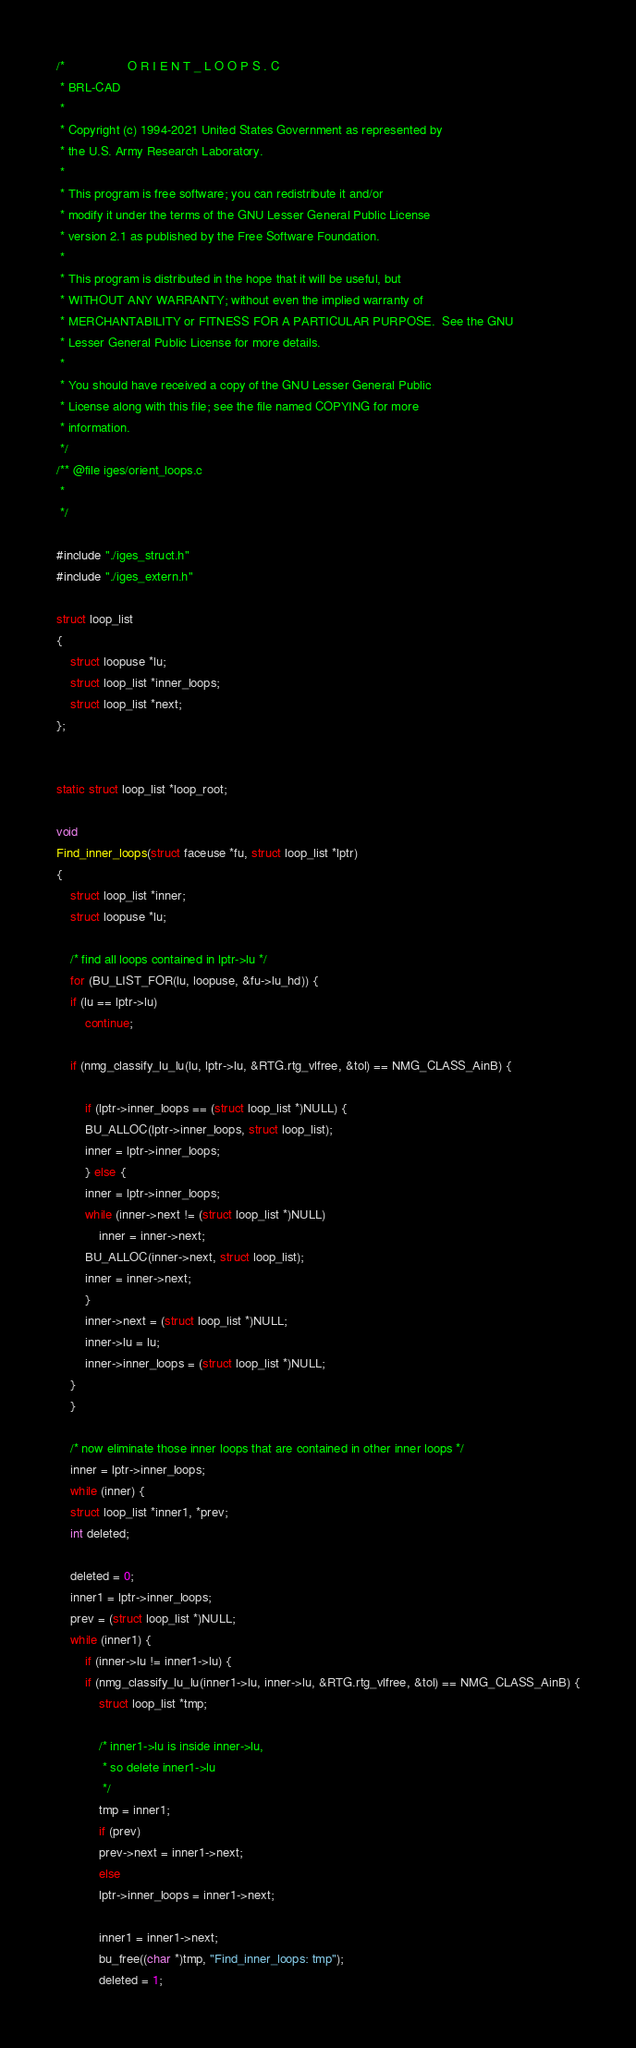<code> <loc_0><loc_0><loc_500><loc_500><_C_>/*                  O R I E N T _ L O O P S . C
 * BRL-CAD
 *
 * Copyright (c) 1994-2021 United States Government as represented by
 * the U.S. Army Research Laboratory.
 *
 * This program is free software; you can redistribute it and/or
 * modify it under the terms of the GNU Lesser General Public License
 * version 2.1 as published by the Free Software Foundation.
 *
 * This program is distributed in the hope that it will be useful, but
 * WITHOUT ANY WARRANTY; without even the implied warranty of
 * MERCHANTABILITY or FITNESS FOR A PARTICULAR PURPOSE.  See the GNU
 * Lesser General Public License for more details.
 *
 * You should have received a copy of the GNU Lesser General Public
 * License along with this file; see the file named COPYING for more
 * information.
 */
/** @file iges/orient_loops.c
 *
 */

#include "./iges_struct.h"
#include "./iges_extern.h"

struct loop_list
{
    struct loopuse *lu;
    struct loop_list *inner_loops;
    struct loop_list *next;
};


static struct loop_list *loop_root;

void
Find_inner_loops(struct faceuse *fu, struct loop_list *lptr)
{
    struct loop_list *inner;
    struct loopuse *lu;

    /* find all loops contained in lptr->lu */
    for (BU_LIST_FOR(lu, loopuse, &fu->lu_hd)) {
	if (lu == lptr->lu)
	    continue;

	if (nmg_classify_lu_lu(lu, lptr->lu, &RTG.rtg_vlfree, &tol) == NMG_CLASS_AinB) {

	    if (lptr->inner_loops == (struct loop_list *)NULL) {
		BU_ALLOC(lptr->inner_loops, struct loop_list);
		inner = lptr->inner_loops;
	    } else {
		inner = lptr->inner_loops;
		while (inner->next != (struct loop_list *)NULL)
		    inner = inner->next;
		BU_ALLOC(inner->next, struct loop_list);
		inner = inner->next;
	    }
	    inner->next = (struct loop_list *)NULL;
	    inner->lu = lu;
	    inner->inner_loops = (struct loop_list *)NULL;
	}
    }

    /* now eliminate those inner loops that are contained in other inner loops */
    inner = lptr->inner_loops;
    while (inner) {
	struct loop_list *inner1, *prev;
	int deleted;

	deleted = 0;
	inner1 = lptr->inner_loops;
	prev = (struct loop_list *)NULL;
	while (inner1) {
	    if (inner->lu != inner1->lu) {
		if (nmg_classify_lu_lu(inner1->lu, inner->lu, &RTG.rtg_vlfree, &tol) == NMG_CLASS_AinB) {
		    struct loop_list *tmp;

		    /* inner1->lu is inside inner->lu,
		     * so delete inner1->lu
		     */
		    tmp = inner1;
		    if (prev)
			prev->next = inner1->next;
		    else
			lptr->inner_loops = inner1->next;

		    inner1 = inner1->next;
		    bu_free((char *)tmp, "Find_inner_loops: tmp");
		    deleted = 1;</code> 